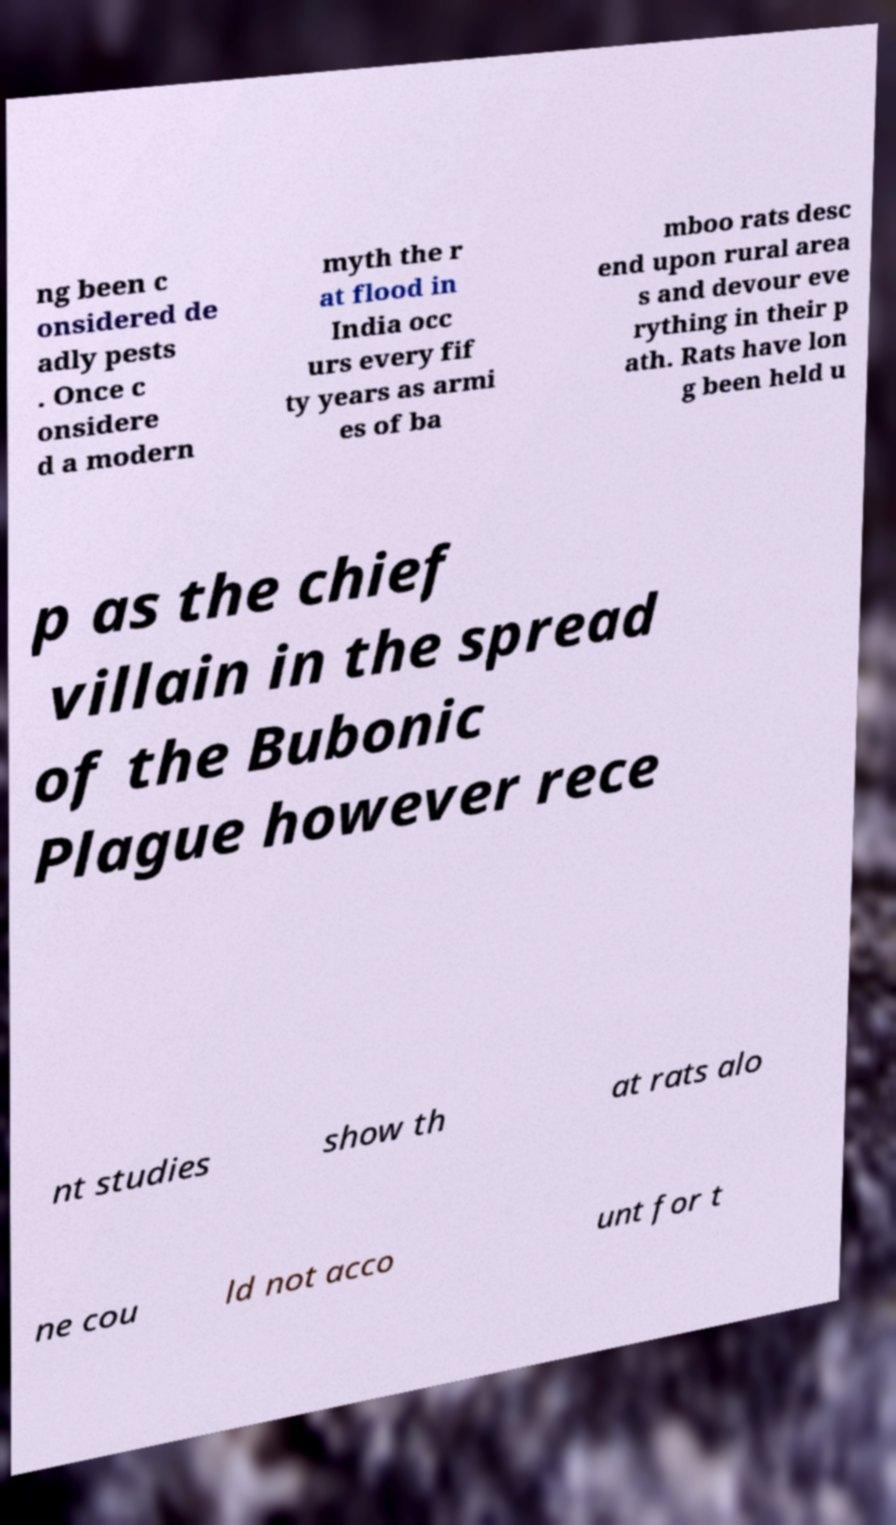Please identify and transcribe the text found in this image. ng been c onsidered de adly pests . Once c onsidere d a modern myth the r at flood in India occ urs every fif ty years as armi es of ba mboo rats desc end upon rural area s and devour eve rything in their p ath. Rats have lon g been held u p as the chief villain in the spread of the Bubonic Plague however rece nt studies show th at rats alo ne cou ld not acco unt for t 